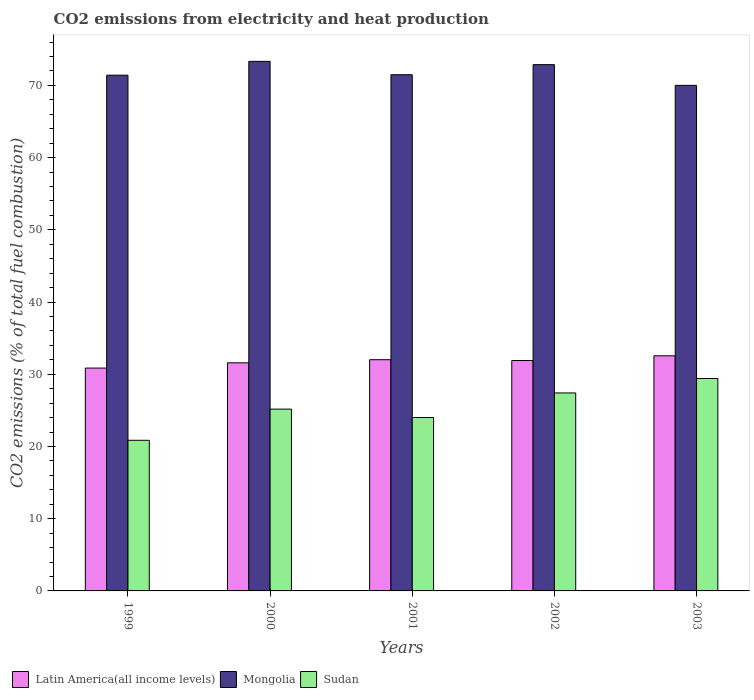How many different coloured bars are there?
Offer a terse response. 3. How many groups of bars are there?
Offer a very short reply. 5. Are the number of bars on each tick of the X-axis equal?
Make the answer very short. Yes. In how many cases, is the number of bars for a given year not equal to the number of legend labels?
Your response must be concise. 0. What is the amount of CO2 emitted in Sudan in 2000?
Keep it short and to the point. 25.17. Across all years, what is the maximum amount of CO2 emitted in Latin America(all income levels)?
Ensure brevity in your answer.  32.56. Across all years, what is the minimum amount of CO2 emitted in Mongolia?
Ensure brevity in your answer.  70. What is the total amount of CO2 emitted in Sudan in the graph?
Your answer should be very brief. 126.87. What is the difference between the amount of CO2 emitted in Sudan in 2000 and that in 2002?
Offer a very short reply. -2.24. What is the difference between the amount of CO2 emitted in Latin America(all income levels) in 2002 and the amount of CO2 emitted in Mongolia in 1999?
Offer a very short reply. -39.51. What is the average amount of CO2 emitted in Sudan per year?
Your answer should be compact. 25.37. In the year 2000, what is the difference between the amount of CO2 emitted in Mongolia and amount of CO2 emitted in Latin America(all income levels)?
Give a very brief answer. 41.74. What is the ratio of the amount of CO2 emitted in Mongolia in 1999 to that in 2001?
Ensure brevity in your answer.  1. Is the amount of CO2 emitted in Sudan in 2001 less than that in 2002?
Your response must be concise. Yes. Is the difference between the amount of CO2 emitted in Mongolia in 2001 and 2003 greater than the difference between the amount of CO2 emitted in Latin America(all income levels) in 2001 and 2003?
Provide a short and direct response. Yes. What is the difference between the highest and the second highest amount of CO2 emitted in Latin America(all income levels)?
Your answer should be very brief. 0.54. What is the difference between the highest and the lowest amount of CO2 emitted in Mongolia?
Your response must be concise. 3.33. In how many years, is the amount of CO2 emitted in Latin America(all income levels) greater than the average amount of CO2 emitted in Latin America(all income levels) taken over all years?
Your answer should be compact. 3. Is the sum of the amount of CO2 emitted in Mongolia in 2000 and 2001 greater than the maximum amount of CO2 emitted in Latin America(all income levels) across all years?
Your answer should be compact. Yes. What does the 1st bar from the left in 2001 represents?
Keep it short and to the point. Latin America(all income levels). What does the 1st bar from the right in 2002 represents?
Ensure brevity in your answer.  Sudan. Are all the bars in the graph horizontal?
Provide a succinct answer. No. How many years are there in the graph?
Offer a very short reply. 5. What is the difference between two consecutive major ticks on the Y-axis?
Your response must be concise. 10. Where does the legend appear in the graph?
Offer a terse response. Bottom left. How are the legend labels stacked?
Make the answer very short. Horizontal. What is the title of the graph?
Ensure brevity in your answer.  CO2 emissions from electricity and heat production. What is the label or title of the X-axis?
Give a very brief answer. Years. What is the label or title of the Y-axis?
Your answer should be compact. CO2 emissions (% of total fuel combustion). What is the CO2 emissions (% of total fuel combustion) in Latin America(all income levels) in 1999?
Provide a short and direct response. 30.86. What is the CO2 emissions (% of total fuel combustion) of Mongolia in 1999?
Give a very brief answer. 71.41. What is the CO2 emissions (% of total fuel combustion) of Sudan in 1999?
Offer a very short reply. 20.86. What is the CO2 emissions (% of total fuel combustion) of Latin America(all income levels) in 2000?
Keep it short and to the point. 31.58. What is the CO2 emissions (% of total fuel combustion) in Mongolia in 2000?
Offer a very short reply. 73.33. What is the CO2 emissions (% of total fuel combustion) in Sudan in 2000?
Ensure brevity in your answer.  25.17. What is the CO2 emissions (% of total fuel combustion) in Latin America(all income levels) in 2001?
Offer a terse response. 32.01. What is the CO2 emissions (% of total fuel combustion) of Mongolia in 2001?
Give a very brief answer. 71.48. What is the CO2 emissions (% of total fuel combustion) in Sudan in 2001?
Offer a terse response. 24.01. What is the CO2 emissions (% of total fuel combustion) of Latin America(all income levels) in 2002?
Provide a short and direct response. 31.9. What is the CO2 emissions (% of total fuel combustion) of Mongolia in 2002?
Your answer should be very brief. 72.87. What is the CO2 emissions (% of total fuel combustion) of Sudan in 2002?
Your answer should be compact. 27.41. What is the CO2 emissions (% of total fuel combustion) in Latin America(all income levels) in 2003?
Ensure brevity in your answer.  32.56. What is the CO2 emissions (% of total fuel combustion) of Sudan in 2003?
Make the answer very short. 29.41. Across all years, what is the maximum CO2 emissions (% of total fuel combustion) of Latin America(all income levels)?
Give a very brief answer. 32.56. Across all years, what is the maximum CO2 emissions (% of total fuel combustion) of Mongolia?
Provide a succinct answer. 73.33. Across all years, what is the maximum CO2 emissions (% of total fuel combustion) of Sudan?
Your response must be concise. 29.41. Across all years, what is the minimum CO2 emissions (% of total fuel combustion) of Latin America(all income levels)?
Make the answer very short. 30.86. Across all years, what is the minimum CO2 emissions (% of total fuel combustion) of Sudan?
Your response must be concise. 20.86. What is the total CO2 emissions (% of total fuel combustion) of Latin America(all income levels) in the graph?
Provide a short and direct response. 158.92. What is the total CO2 emissions (% of total fuel combustion) in Mongolia in the graph?
Offer a terse response. 359.09. What is the total CO2 emissions (% of total fuel combustion) in Sudan in the graph?
Keep it short and to the point. 126.87. What is the difference between the CO2 emissions (% of total fuel combustion) of Latin America(all income levels) in 1999 and that in 2000?
Keep it short and to the point. -0.73. What is the difference between the CO2 emissions (% of total fuel combustion) of Mongolia in 1999 and that in 2000?
Your answer should be very brief. -1.91. What is the difference between the CO2 emissions (% of total fuel combustion) of Sudan in 1999 and that in 2000?
Provide a short and direct response. -4.32. What is the difference between the CO2 emissions (% of total fuel combustion) in Latin America(all income levels) in 1999 and that in 2001?
Make the answer very short. -1.16. What is the difference between the CO2 emissions (% of total fuel combustion) in Mongolia in 1999 and that in 2001?
Give a very brief answer. -0.07. What is the difference between the CO2 emissions (% of total fuel combustion) in Sudan in 1999 and that in 2001?
Make the answer very short. -3.16. What is the difference between the CO2 emissions (% of total fuel combustion) in Latin America(all income levels) in 1999 and that in 2002?
Provide a short and direct response. -1.04. What is the difference between the CO2 emissions (% of total fuel combustion) of Mongolia in 1999 and that in 2002?
Give a very brief answer. -1.46. What is the difference between the CO2 emissions (% of total fuel combustion) of Sudan in 1999 and that in 2002?
Keep it short and to the point. -6.56. What is the difference between the CO2 emissions (% of total fuel combustion) in Latin America(all income levels) in 1999 and that in 2003?
Provide a succinct answer. -1.7. What is the difference between the CO2 emissions (% of total fuel combustion) of Mongolia in 1999 and that in 2003?
Your answer should be compact. 1.41. What is the difference between the CO2 emissions (% of total fuel combustion) in Sudan in 1999 and that in 2003?
Keep it short and to the point. -8.56. What is the difference between the CO2 emissions (% of total fuel combustion) in Latin America(all income levels) in 2000 and that in 2001?
Provide a succinct answer. -0.43. What is the difference between the CO2 emissions (% of total fuel combustion) in Mongolia in 2000 and that in 2001?
Make the answer very short. 1.85. What is the difference between the CO2 emissions (% of total fuel combustion) in Sudan in 2000 and that in 2001?
Provide a short and direct response. 1.16. What is the difference between the CO2 emissions (% of total fuel combustion) of Latin America(all income levels) in 2000 and that in 2002?
Offer a very short reply. -0.32. What is the difference between the CO2 emissions (% of total fuel combustion) of Mongolia in 2000 and that in 2002?
Give a very brief answer. 0.45. What is the difference between the CO2 emissions (% of total fuel combustion) of Sudan in 2000 and that in 2002?
Provide a succinct answer. -2.24. What is the difference between the CO2 emissions (% of total fuel combustion) in Latin America(all income levels) in 2000 and that in 2003?
Your answer should be very brief. -0.97. What is the difference between the CO2 emissions (% of total fuel combustion) of Mongolia in 2000 and that in 2003?
Make the answer very short. 3.33. What is the difference between the CO2 emissions (% of total fuel combustion) in Sudan in 2000 and that in 2003?
Your answer should be compact. -4.24. What is the difference between the CO2 emissions (% of total fuel combustion) of Latin America(all income levels) in 2001 and that in 2002?
Give a very brief answer. 0.11. What is the difference between the CO2 emissions (% of total fuel combustion) of Mongolia in 2001 and that in 2002?
Provide a short and direct response. -1.4. What is the difference between the CO2 emissions (% of total fuel combustion) in Sudan in 2001 and that in 2002?
Provide a succinct answer. -3.4. What is the difference between the CO2 emissions (% of total fuel combustion) of Latin America(all income levels) in 2001 and that in 2003?
Your response must be concise. -0.54. What is the difference between the CO2 emissions (% of total fuel combustion) of Mongolia in 2001 and that in 2003?
Offer a very short reply. 1.48. What is the difference between the CO2 emissions (% of total fuel combustion) in Sudan in 2001 and that in 2003?
Ensure brevity in your answer.  -5.4. What is the difference between the CO2 emissions (% of total fuel combustion) in Latin America(all income levels) in 2002 and that in 2003?
Provide a short and direct response. -0.66. What is the difference between the CO2 emissions (% of total fuel combustion) in Mongolia in 2002 and that in 2003?
Provide a succinct answer. 2.87. What is the difference between the CO2 emissions (% of total fuel combustion) in Sudan in 2002 and that in 2003?
Provide a succinct answer. -2. What is the difference between the CO2 emissions (% of total fuel combustion) in Latin America(all income levels) in 1999 and the CO2 emissions (% of total fuel combustion) in Mongolia in 2000?
Offer a very short reply. -42.47. What is the difference between the CO2 emissions (% of total fuel combustion) in Latin America(all income levels) in 1999 and the CO2 emissions (% of total fuel combustion) in Sudan in 2000?
Provide a short and direct response. 5.68. What is the difference between the CO2 emissions (% of total fuel combustion) of Mongolia in 1999 and the CO2 emissions (% of total fuel combustion) of Sudan in 2000?
Your answer should be very brief. 46.24. What is the difference between the CO2 emissions (% of total fuel combustion) of Latin America(all income levels) in 1999 and the CO2 emissions (% of total fuel combustion) of Mongolia in 2001?
Offer a terse response. -40.62. What is the difference between the CO2 emissions (% of total fuel combustion) in Latin America(all income levels) in 1999 and the CO2 emissions (% of total fuel combustion) in Sudan in 2001?
Make the answer very short. 6.84. What is the difference between the CO2 emissions (% of total fuel combustion) of Mongolia in 1999 and the CO2 emissions (% of total fuel combustion) of Sudan in 2001?
Offer a very short reply. 47.4. What is the difference between the CO2 emissions (% of total fuel combustion) in Latin America(all income levels) in 1999 and the CO2 emissions (% of total fuel combustion) in Mongolia in 2002?
Your answer should be compact. -42.02. What is the difference between the CO2 emissions (% of total fuel combustion) in Latin America(all income levels) in 1999 and the CO2 emissions (% of total fuel combustion) in Sudan in 2002?
Offer a very short reply. 3.44. What is the difference between the CO2 emissions (% of total fuel combustion) in Mongolia in 1999 and the CO2 emissions (% of total fuel combustion) in Sudan in 2002?
Your answer should be very brief. 44. What is the difference between the CO2 emissions (% of total fuel combustion) of Latin America(all income levels) in 1999 and the CO2 emissions (% of total fuel combustion) of Mongolia in 2003?
Provide a succinct answer. -39.14. What is the difference between the CO2 emissions (% of total fuel combustion) of Latin America(all income levels) in 1999 and the CO2 emissions (% of total fuel combustion) of Sudan in 2003?
Your answer should be compact. 1.45. What is the difference between the CO2 emissions (% of total fuel combustion) in Mongolia in 1999 and the CO2 emissions (% of total fuel combustion) in Sudan in 2003?
Provide a short and direct response. 42. What is the difference between the CO2 emissions (% of total fuel combustion) in Latin America(all income levels) in 2000 and the CO2 emissions (% of total fuel combustion) in Mongolia in 2001?
Your answer should be very brief. -39.89. What is the difference between the CO2 emissions (% of total fuel combustion) in Latin America(all income levels) in 2000 and the CO2 emissions (% of total fuel combustion) in Sudan in 2001?
Make the answer very short. 7.57. What is the difference between the CO2 emissions (% of total fuel combustion) of Mongolia in 2000 and the CO2 emissions (% of total fuel combustion) of Sudan in 2001?
Offer a very short reply. 49.31. What is the difference between the CO2 emissions (% of total fuel combustion) in Latin America(all income levels) in 2000 and the CO2 emissions (% of total fuel combustion) in Mongolia in 2002?
Provide a short and direct response. -41.29. What is the difference between the CO2 emissions (% of total fuel combustion) of Latin America(all income levels) in 2000 and the CO2 emissions (% of total fuel combustion) of Sudan in 2002?
Offer a terse response. 4.17. What is the difference between the CO2 emissions (% of total fuel combustion) in Mongolia in 2000 and the CO2 emissions (% of total fuel combustion) in Sudan in 2002?
Ensure brevity in your answer.  45.91. What is the difference between the CO2 emissions (% of total fuel combustion) of Latin America(all income levels) in 2000 and the CO2 emissions (% of total fuel combustion) of Mongolia in 2003?
Your answer should be compact. -38.42. What is the difference between the CO2 emissions (% of total fuel combustion) of Latin America(all income levels) in 2000 and the CO2 emissions (% of total fuel combustion) of Sudan in 2003?
Keep it short and to the point. 2.17. What is the difference between the CO2 emissions (% of total fuel combustion) in Mongolia in 2000 and the CO2 emissions (% of total fuel combustion) in Sudan in 2003?
Offer a terse response. 43.91. What is the difference between the CO2 emissions (% of total fuel combustion) in Latin America(all income levels) in 2001 and the CO2 emissions (% of total fuel combustion) in Mongolia in 2002?
Your answer should be compact. -40.86. What is the difference between the CO2 emissions (% of total fuel combustion) in Latin America(all income levels) in 2001 and the CO2 emissions (% of total fuel combustion) in Sudan in 2002?
Keep it short and to the point. 4.6. What is the difference between the CO2 emissions (% of total fuel combustion) in Mongolia in 2001 and the CO2 emissions (% of total fuel combustion) in Sudan in 2002?
Your response must be concise. 44.06. What is the difference between the CO2 emissions (% of total fuel combustion) in Latin America(all income levels) in 2001 and the CO2 emissions (% of total fuel combustion) in Mongolia in 2003?
Provide a short and direct response. -37.98. What is the difference between the CO2 emissions (% of total fuel combustion) of Latin America(all income levels) in 2001 and the CO2 emissions (% of total fuel combustion) of Sudan in 2003?
Offer a terse response. 2.6. What is the difference between the CO2 emissions (% of total fuel combustion) in Mongolia in 2001 and the CO2 emissions (% of total fuel combustion) in Sudan in 2003?
Provide a succinct answer. 42.07. What is the difference between the CO2 emissions (% of total fuel combustion) in Latin America(all income levels) in 2002 and the CO2 emissions (% of total fuel combustion) in Mongolia in 2003?
Your answer should be very brief. -38.1. What is the difference between the CO2 emissions (% of total fuel combustion) of Latin America(all income levels) in 2002 and the CO2 emissions (% of total fuel combustion) of Sudan in 2003?
Provide a short and direct response. 2.49. What is the difference between the CO2 emissions (% of total fuel combustion) of Mongolia in 2002 and the CO2 emissions (% of total fuel combustion) of Sudan in 2003?
Your answer should be compact. 43.46. What is the average CO2 emissions (% of total fuel combustion) of Latin America(all income levels) per year?
Your answer should be compact. 31.78. What is the average CO2 emissions (% of total fuel combustion) of Mongolia per year?
Provide a short and direct response. 71.82. What is the average CO2 emissions (% of total fuel combustion) of Sudan per year?
Offer a very short reply. 25.37. In the year 1999, what is the difference between the CO2 emissions (% of total fuel combustion) of Latin America(all income levels) and CO2 emissions (% of total fuel combustion) of Mongolia?
Offer a very short reply. -40.55. In the year 1999, what is the difference between the CO2 emissions (% of total fuel combustion) of Latin America(all income levels) and CO2 emissions (% of total fuel combustion) of Sudan?
Keep it short and to the point. 10. In the year 1999, what is the difference between the CO2 emissions (% of total fuel combustion) in Mongolia and CO2 emissions (% of total fuel combustion) in Sudan?
Your response must be concise. 50.55. In the year 2000, what is the difference between the CO2 emissions (% of total fuel combustion) in Latin America(all income levels) and CO2 emissions (% of total fuel combustion) in Mongolia?
Your response must be concise. -41.74. In the year 2000, what is the difference between the CO2 emissions (% of total fuel combustion) of Latin America(all income levels) and CO2 emissions (% of total fuel combustion) of Sudan?
Provide a succinct answer. 6.41. In the year 2000, what is the difference between the CO2 emissions (% of total fuel combustion) in Mongolia and CO2 emissions (% of total fuel combustion) in Sudan?
Offer a terse response. 48.15. In the year 2001, what is the difference between the CO2 emissions (% of total fuel combustion) of Latin America(all income levels) and CO2 emissions (% of total fuel combustion) of Mongolia?
Provide a short and direct response. -39.46. In the year 2001, what is the difference between the CO2 emissions (% of total fuel combustion) in Latin America(all income levels) and CO2 emissions (% of total fuel combustion) in Sudan?
Your response must be concise. 8. In the year 2001, what is the difference between the CO2 emissions (% of total fuel combustion) in Mongolia and CO2 emissions (% of total fuel combustion) in Sudan?
Offer a terse response. 47.46. In the year 2002, what is the difference between the CO2 emissions (% of total fuel combustion) in Latin America(all income levels) and CO2 emissions (% of total fuel combustion) in Mongolia?
Give a very brief answer. -40.97. In the year 2002, what is the difference between the CO2 emissions (% of total fuel combustion) of Latin America(all income levels) and CO2 emissions (% of total fuel combustion) of Sudan?
Offer a terse response. 4.49. In the year 2002, what is the difference between the CO2 emissions (% of total fuel combustion) of Mongolia and CO2 emissions (% of total fuel combustion) of Sudan?
Your response must be concise. 45.46. In the year 2003, what is the difference between the CO2 emissions (% of total fuel combustion) in Latin America(all income levels) and CO2 emissions (% of total fuel combustion) in Mongolia?
Your answer should be compact. -37.44. In the year 2003, what is the difference between the CO2 emissions (% of total fuel combustion) in Latin America(all income levels) and CO2 emissions (% of total fuel combustion) in Sudan?
Your answer should be very brief. 3.15. In the year 2003, what is the difference between the CO2 emissions (% of total fuel combustion) in Mongolia and CO2 emissions (% of total fuel combustion) in Sudan?
Your answer should be compact. 40.59. What is the ratio of the CO2 emissions (% of total fuel combustion) of Latin America(all income levels) in 1999 to that in 2000?
Ensure brevity in your answer.  0.98. What is the ratio of the CO2 emissions (% of total fuel combustion) of Mongolia in 1999 to that in 2000?
Your answer should be very brief. 0.97. What is the ratio of the CO2 emissions (% of total fuel combustion) of Sudan in 1999 to that in 2000?
Offer a terse response. 0.83. What is the ratio of the CO2 emissions (% of total fuel combustion) of Latin America(all income levels) in 1999 to that in 2001?
Offer a very short reply. 0.96. What is the ratio of the CO2 emissions (% of total fuel combustion) in Sudan in 1999 to that in 2001?
Ensure brevity in your answer.  0.87. What is the ratio of the CO2 emissions (% of total fuel combustion) of Latin America(all income levels) in 1999 to that in 2002?
Ensure brevity in your answer.  0.97. What is the ratio of the CO2 emissions (% of total fuel combustion) in Mongolia in 1999 to that in 2002?
Offer a terse response. 0.98. What is the ratio of the CO2 emissions (% of total fuel combustion) in Sudan in 1999 to that in 2002?
Provide a succinct answer. 0.76. What is the ratio of the CO2 emissions (% of total fuel combustion) in Latin America(all income levels) in 1999 to that in 2003?
Make the answer very short. 0.95. What is the ratio of the CO2 emissions (% of total fuel combustion) in Mongolia in 1999 to that in 2003?
Your response must be concise. 1.02. What is the ratio of the CO2 emissions (% of total fuel combustion) in Sudan in 1999 to that in 2003?
Offer a terse response. 0.71. What is the ratio of the CO2 emissions (% of total fuel combustion) of Latin America(all income levels) in 2000 to that in 2001?
Give a very brief answer. 0.99. What is the ratio of the CO2 emissions (% of total fuel combustion) of Mongolia in 2000 to that in 2001?
Offer a very short reply. 1.03. What is the ratio of the CO2 emissions (% of total fuel combustion) of Sudan in 2000 to that in 2001?
Offer a very short reply. 1.05. What is the ratio of the CO2 emissions (% of total fuel combustion) in Sudan in 2000 to that in 2002?
Your answer should be compact. 0.92. What is the ratio of the CO2 emissions (% of total fuel combustion) in Latin America(all income levels) in 2000 to that in 2003?
Ensure brevity in your answer.  0.97. What is the ratio of the CO2 emissions (% of total fuel combustion) in Mongolia in 2000 to that in 2003?
Your answer should be compact. 1.05. What is the ratio of the CO2 emissions (% of total fuel combustion) in Sudan in 2000 to that in 2003?
Make the answer very short. 0.86. What is the ratio of the CO2 emissions (% of total fuel combustion) of Mongolia in 2001 to that in 2002?
Provide a short and direct response. 0.98. What is the ratio of the CO2 emissions (% of total fuel combustion) in Sudan in 2001 to that in 2002?
Your answer should be very brief. 0.88. What is the ratio of the CO2 emissions (% of total fuel combustion) in Latin America(all income levels) in 2001 to that in 2003?
Keep it short and to the point. 0.98. What is the ratio of the CO2 emissions (% of total fuel combustion) of Mongolia in 2001 to that in 2003?
Give a very brief answer. 1.02. What is the ratio of the CO2 emissions (% of total fuel combustion) in Sudan in 2001 to that in 2003?
Ensure brevity in your answer.  0.82. What is the ratio of the CO2 emissions (% of total fuel combustion) of Latin America(all income levels) in 2002 to that in 2003?
Offer a very short reply. 0.98. What is the ratio of the CO2 emissions (% of total fuel combustion) in Mongolia in 2002 to that in 2003?
Your answer should be very brief. 1.04. What is the ratio of the CO2 emissions (% of total fuel combustion) of Sudan in 2002 to that in 2003?
Offer a very short reply. 0.93. What is the difference between the highest and the second highest CO2 emissions (% of total fuel combustion) in Latin America(all income levels)?
Your response must be concise. 0.54. What is the difference between the highest and the second highest CO2 emissions (% of total fuel combustion) of Mongolia?
Give a very brief answer. 0.45. What is the difference between the highest and the second highest CO2 emissions (% of total fuel combustion) of Sudan?
Your answer should be very brief. 2. What is the difference between the highest and the lowest CO2 emissions (% of total fuel combustion) of Latin America(all income levels)?
Offer a terse response. 1.7. What is the difference between the highest and the lowest CO2 emissions (% of total fuel combustion) of Mongolia?
Provide a short and direct response. 3.33. What is the difference between the highest and the lowest CO2 emissions (% of total fuel combustion) of Sudan?
Ensure brevity in your answer.  8.56. 